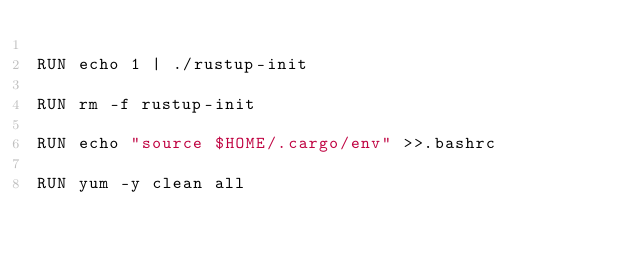<code> <loc_0><loc_0><loc_500><loc_500><_Dockerfile_>
RUN echo 1 | ./rustup-init

RUN rm -f rustup-init

RUN echo "source $HOME/.cargo/env" >>.bashrc

RUN yum -y clean all


</code> 